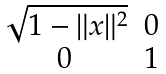<formula> <loc_0><loc_0><loc_500><loc_500>\begin{matrix} \sqrt { 1 - \| x \| ^ { 2 } } & 0 \\ 0 & 1 \end{matrix}</formula> 